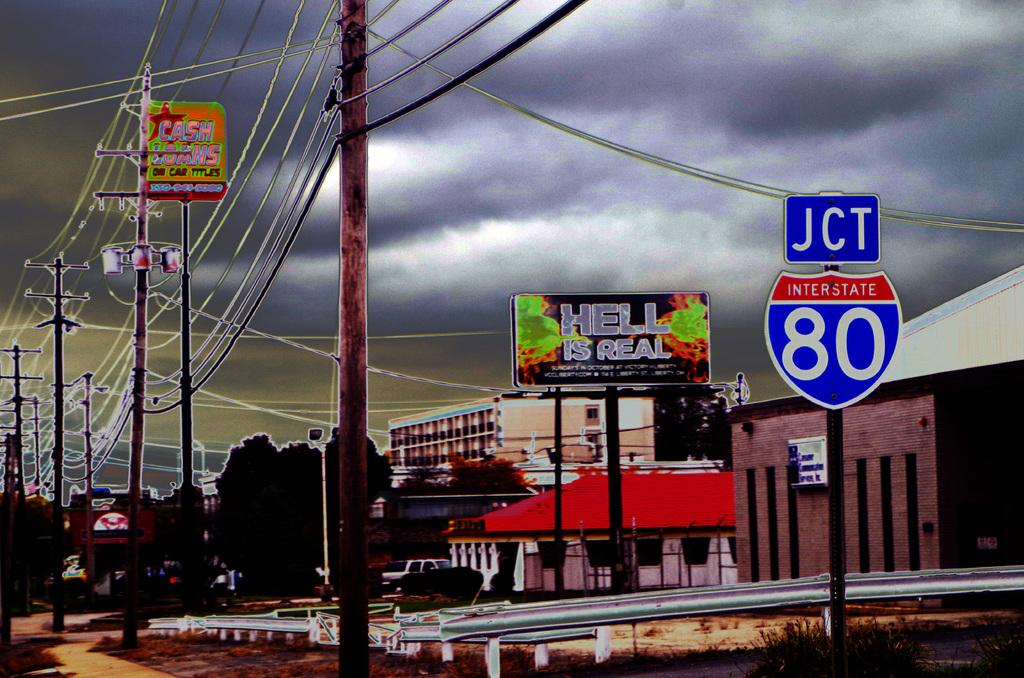Provide a one-sentence caption for the provided image. JCT Interstate 80 displaying a sign stating Hell is real. 